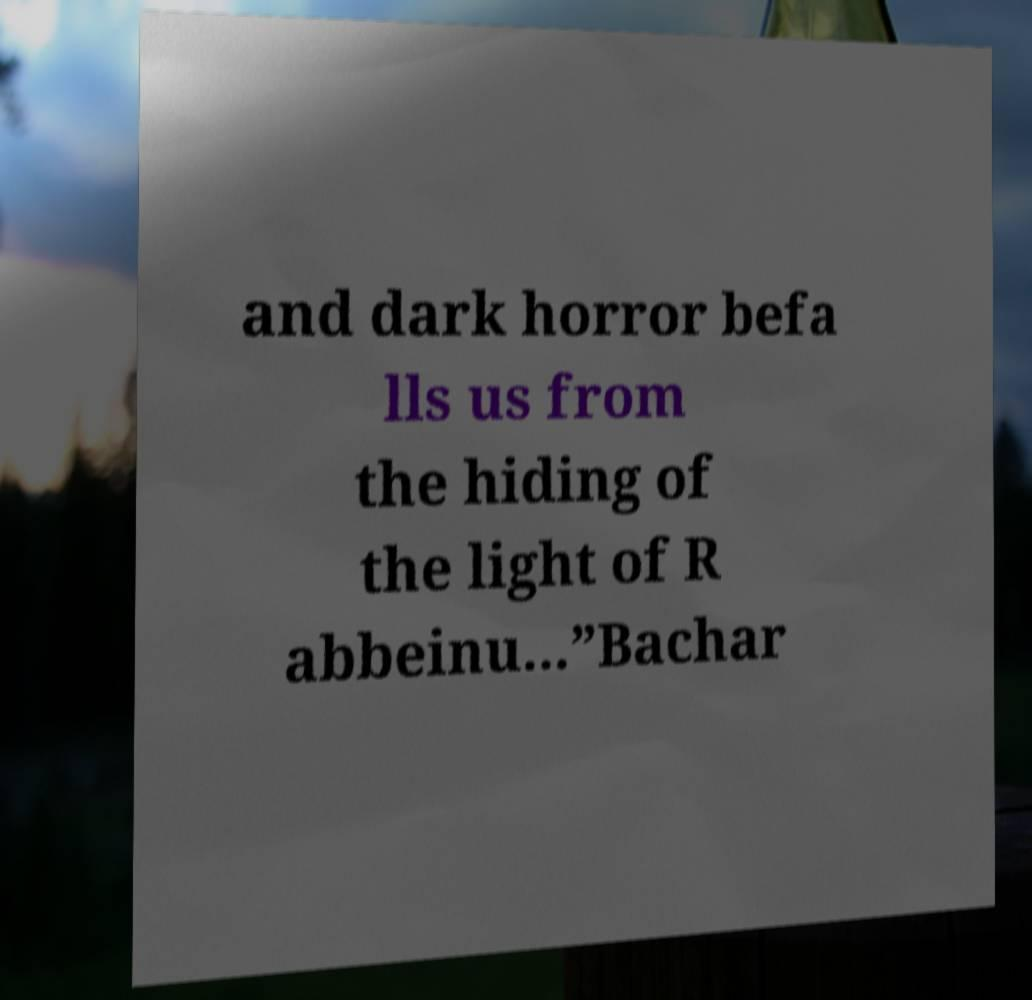For documentation purposes, I need the text within this image transcribed. Could you provide that? and dark horror befa lls us from the hiding of the light of R abbeinu...”Bachar 